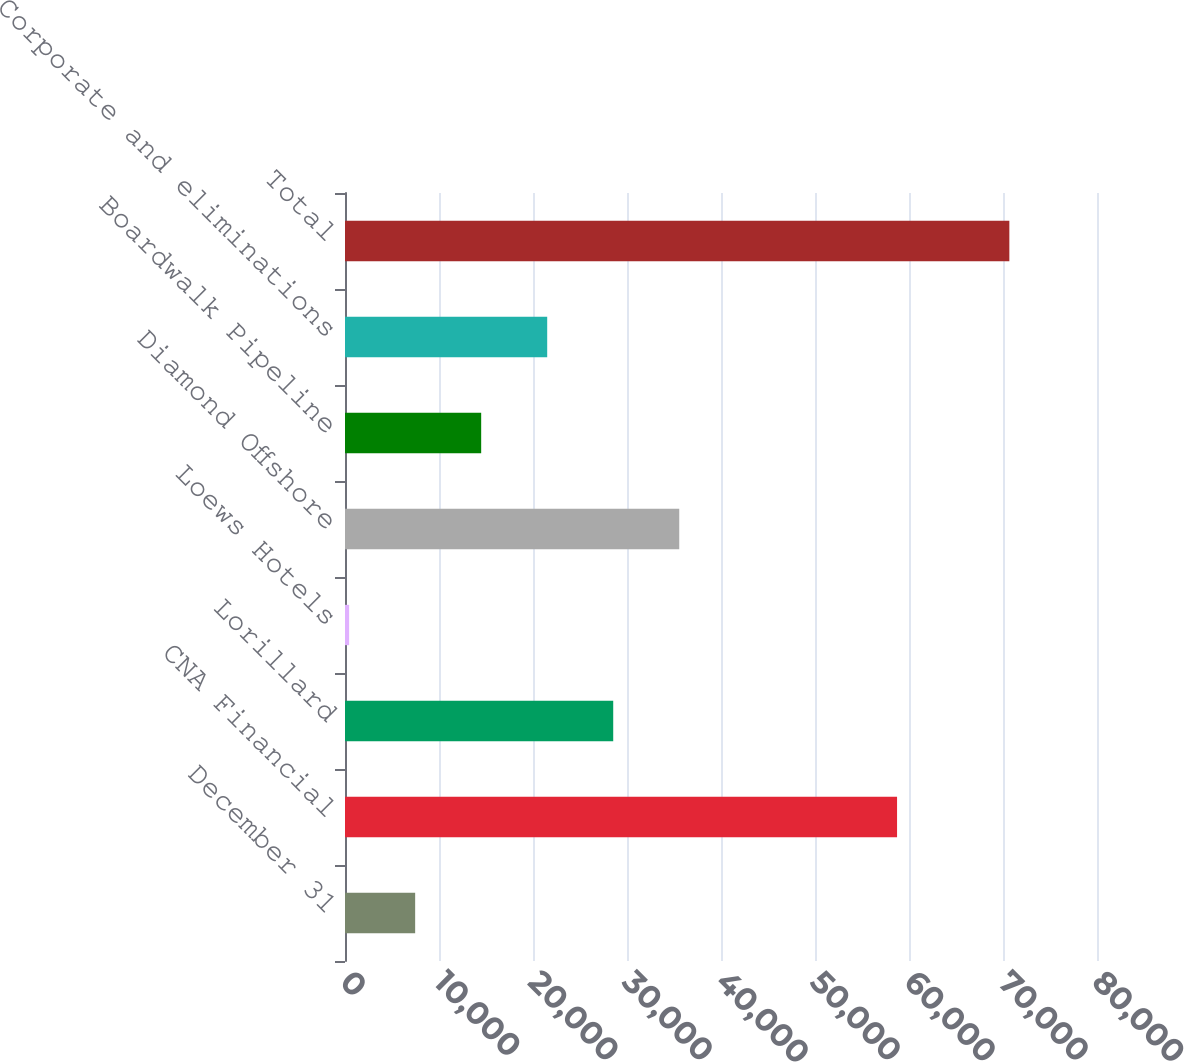<chart> <loc_0><loc_0><loc_500><loc_500><bar_chart><fcel>December 31<fcel>CNA Financial<fcel>Lorillard<fcel>Loews Hotels<fcel>Diamond Offshore<fcel>Boardwalk Pipeline<fcel>Corporate and eliminations<fcel>Total<nl><fcel>7463.65<fcel>58730<fcel>28534.3<fcel>440.1<fcel>35557.8<fcel>14487.2<fcel>21510.8<fcel>70675.6<nl></chart> 